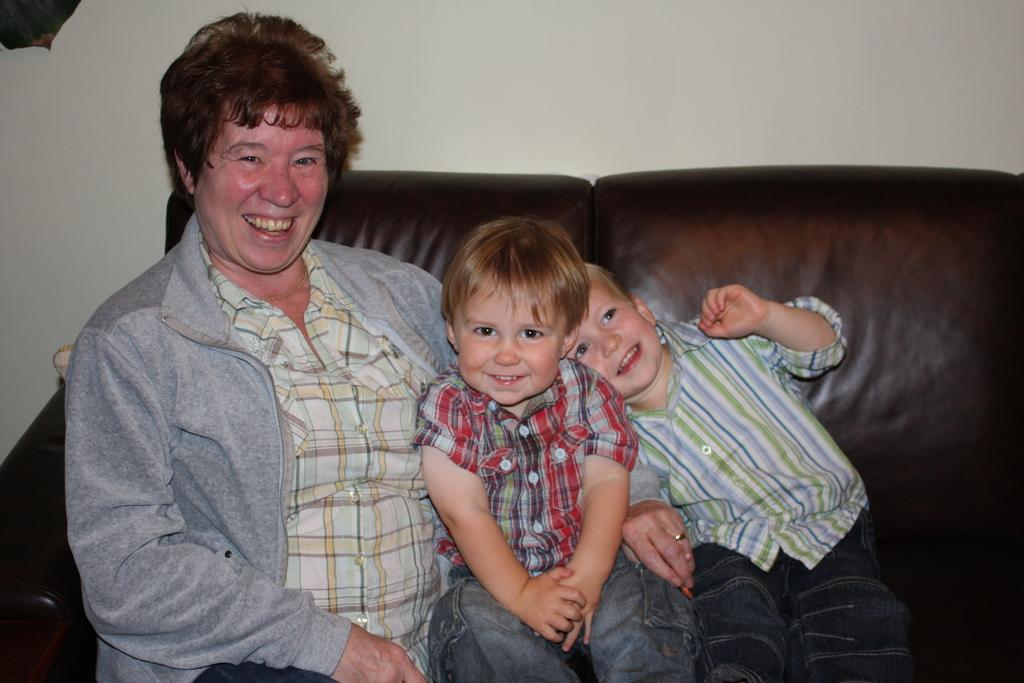Who is present in the image? There is a person and two kids in the image. What are they doing in the image? The person and the kids are sitting on a sofa. What is the emotional expression of the people in the image? They are smiling. What can be seen in the background of the image? There is a wall in the background of the image. What type of rake is being used by the person in the image? There is no rake present in the image. How much credit does the person in the image have on their account? There is no information about the person's credit in the image. Can you see any animals from the zoo in the image? There are no animals from the zoo visible in the image. 